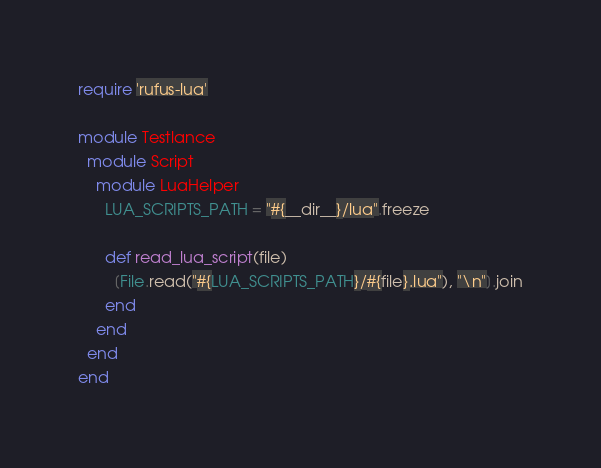<code> <loc_0><loc_0><loc_500><loc_500><_Ruby_>require 'rufus-lua'

module Testlance
  module Script
    module LuaHelper
      LUA_SCRIPTS_PATH = "#{__dir__}/lua".freeze

      def read_lua_script(file)
        [File.read("#{LUA_SCRIPTS_PATH}/#{file}.lua"), "\n"].join
      end
    end
  end
end
</code> 